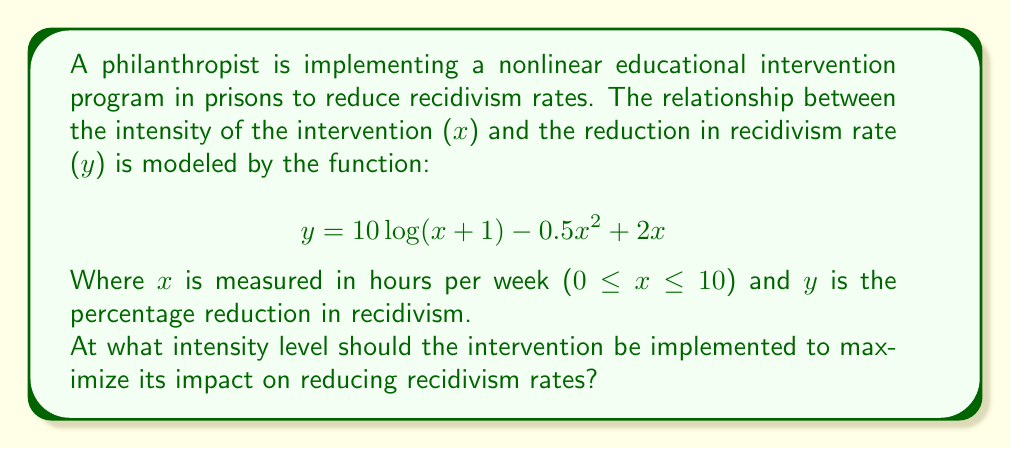Can you answer this question? To find the maximum impact of the intervention, we need to find the value of x that maximizes the function y. This can be done by following these steps:

1) First, we need to find the derivative of y with respect to x:

   $$\frac{dy}{dx} = \frac{10}{x+1} - x + 2$$

2) To find the maximum, we set the derivative equal to zero and solve for x:

   $$\frac{10}{x+1} - x + 2 = 0$$

3) Multiply both sides by (x+1):

   $$10 - x(x+1) + 2(x+1) = 0$$

4) Expand:

   $$10 - x^2 - x + 2x + 2 = 0$$
   $$-x^2 + x + 12 = 0$$

5) This is a quadratic equation. We can solve it using the quadratic formula:

   $$x = \frac{-b \pm \sqrt{b^2 - 4ac}}{2a}$$

   Where a = -1, b = 1, and c = 12

6) Plugging in these values:

   $$x = \frac{-1 \pm \sqrt{1^2 - 4(-1)(12)}}{2(-1)}$$
   $$x = \frac{-1 \pm \sqrt{49}}{-2}$$
   $$x = \frac{-1 \pm 7}{-2}$$

7) This gives us two solutions:

   $$x = \frac{-1 + 7}{-2} = -3$$ or $$x = \frac{-1 - 7}{-2} = 4$$

8) Since x represents hours and must be non-negative, we discard the negative solution. Also, we need to check if x = 4 is within our domain (0 ≤ x ≤ 10), which it is.

9) To confirm this is a maximum (not a minimum), we can check the second derivative:

   $$\frac{d^2y}{dx^2} = -\frac{10}{(x+1)^2} - 1$$

   At x = 4, this is negative, confirming a maximum.

Therefore, the intervention should be implemented at an intensity of 4 hours per week to maximize its impact on reducing recidivism rates.
Answer: 4 hours per week 